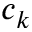<formula> <loc_0><loc_0><loc_500><loc_500>c _ { k }</formula> 